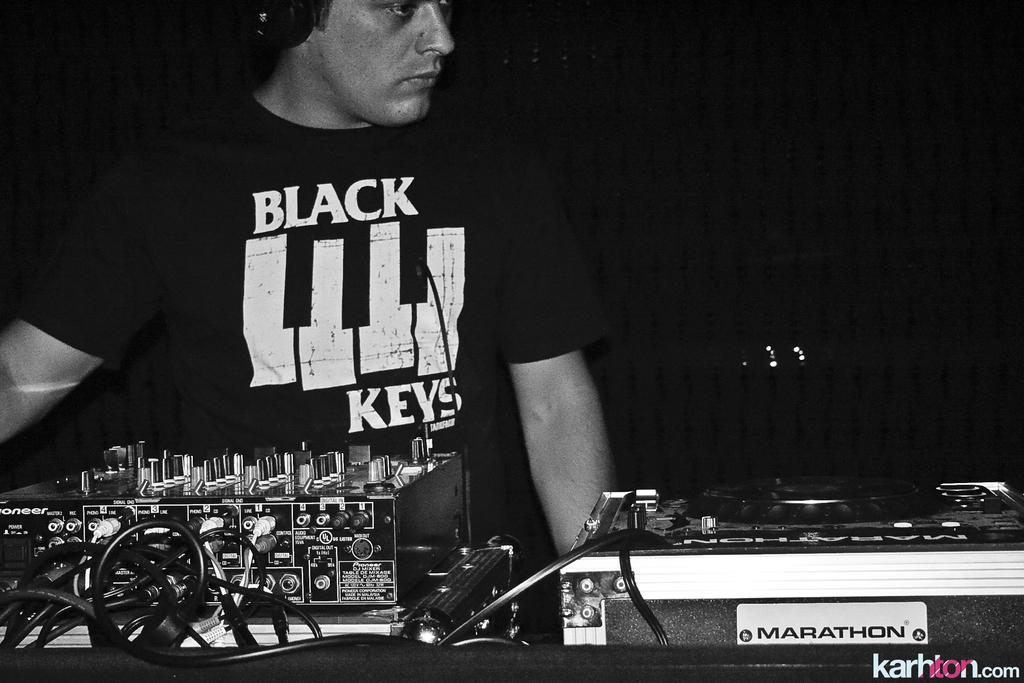What is the color scheme of the image? The image is black and white. What equipment is visible in the image? There are music mixers in the image. Can you describe the person in the image? There is a person in the image. What is the person wearing? The person is wearing clothes. What type of letter is the person holding in the image? There is no letter present in the image; the person is not holding anything. 